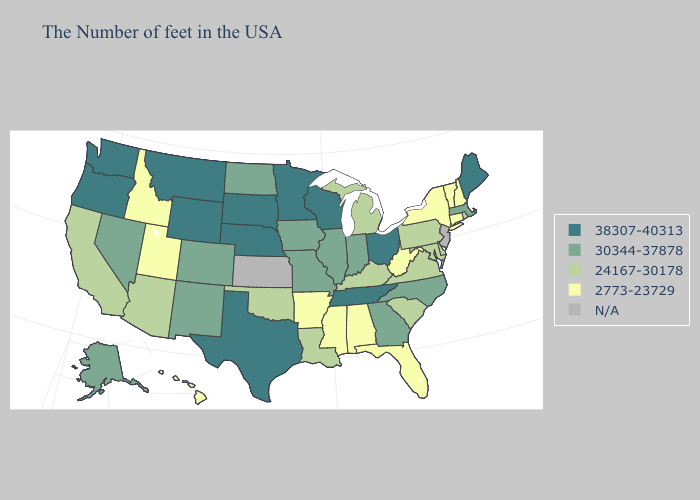What is the value of New Jersey?
Concise answer only. N/A. Name the states that have a value in the range 30344-37878?
Write a very short answer. Massachusetts, North Carolina, Georgia, Indiana, Illinois, Missouri, Iowa, North Dakota, Colorado, New Mexico, Nevada, Alaska. Name the states that have a value in the range 30344-37878?
Quick response, please. Massachusetts, North Carolina, Georgia, Indiana, Illinois, Missouri, Iowa, North Dakota, Colorado, New Mexico, Nevada, Alaska. Name the states that have a value in the range 2773-23729?
Short answer required. New Hampshire, Vermont, Connecticut, New York, West Virginia, Florida, Alabama, Mississippi, Arkansas, Utah, Idaho, Hawaii. Name the states that have a value in the range 2773-23729?
Quick response, please. New Hampshire, Vermont, Connecticut, New York, West Virginia, Florida, Alabama, Mississippi, Arkansas, Utah, Idaho, Hawaii. Does Alaska have the highest value in the West?
Give a very brief answer. No. What is the lowest value in the MidWest?
Concise answer only. 24167-30178. Is the legend a continuous bar?
Write a very short answer. No. Among the states that border New Jersey , which have the highest value?
Short answer required. Delaware, Pennsylvania. Which states have the highest value in the USA?
Short answer required. Maine, Ohio, Tennessee, Wisconsin, Minnesota, Nebraska, Texas, South Dakota, Wyoming, Montana, Washington, Oregon. Name the states that have a value in the range 2773-23729?
Short answer required. New Hampshire, Vermont, Connecticut, New York, West Virginia, Florida, Alabama, Mississippi, Arkansas, Utah, Idaho, Hawaii. What is the highest value in the MidWest ?
Give a very brief answer. 38307-40313. Among the states that border Wyoming , which have the highest value?
Answer briefly. Nebraska, South Dakota, Montana. Name the states that have a value in the range 2773-23729?
Write a very short answer. New Hampshire, Vermont, Connecticut, New York, West Virginia, Florida, Alabama, Mississippi, Arkansas, Utah, Idaho, Hawaii. 